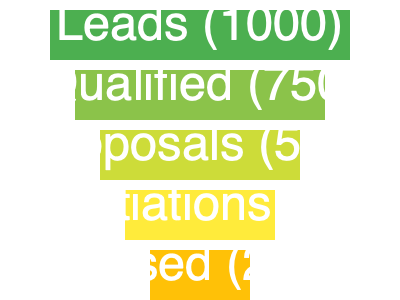Based on the sales funnel chart, what is the conversion rate from the "Proposals" stage to the "Closed" stage? To calculate the conversion rate from the "Proposals" stage to the "Closed" stage, we need to follow these steps:

1. Identify the number of leads at the "Proposals" stage: 500
2. Identify the number of leads at the "Closed" stage: 200
3. Calculate the conversion rate using the formula:
   Conversion Rate = (Number of Closed Deals / Number of Proposals) × 100

Let's plug in the numbers:
Conversion Rate = (200 / 500) × 100
               = 0.4 × 100
               = 40%

Therefore, the conversion rate from the "Proposals" stage to the "Closed" stage is 40%.
Answer: 40% 